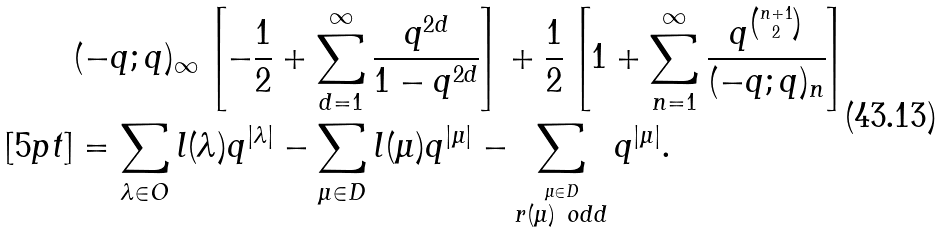<formula> <loc_0><loc_0><loc_500><loc_500>& ( - q ; q ) _ { \infty } \left [ - \frac { 1 } { 2 } + \sum _ { d = 1 } ^ { \infty } \frac { q ^ { 2 d } } { 1 - q ^ { 2 d } } \right ] + \frac { 1 } { 2 } \left [ 1 + \sum _ { n = 1 } ^ { \infty } \frac { q ^ { n + 1 \choose 2 } } { ( - q ; q ) _ { n } } \right ] \\ [ 5 p t ] & = \sum _ { \lambda \in O } l ( \lambda ) q ^ { | \lambda | } - \sum _ { \mu \in D } l ( \mu ) q ^ { | \mu | } - \sum _ { \stackrel { \mu \in D } { r ( \mu ) \ o d d } } q ^ { | \mu | } .</formula> 